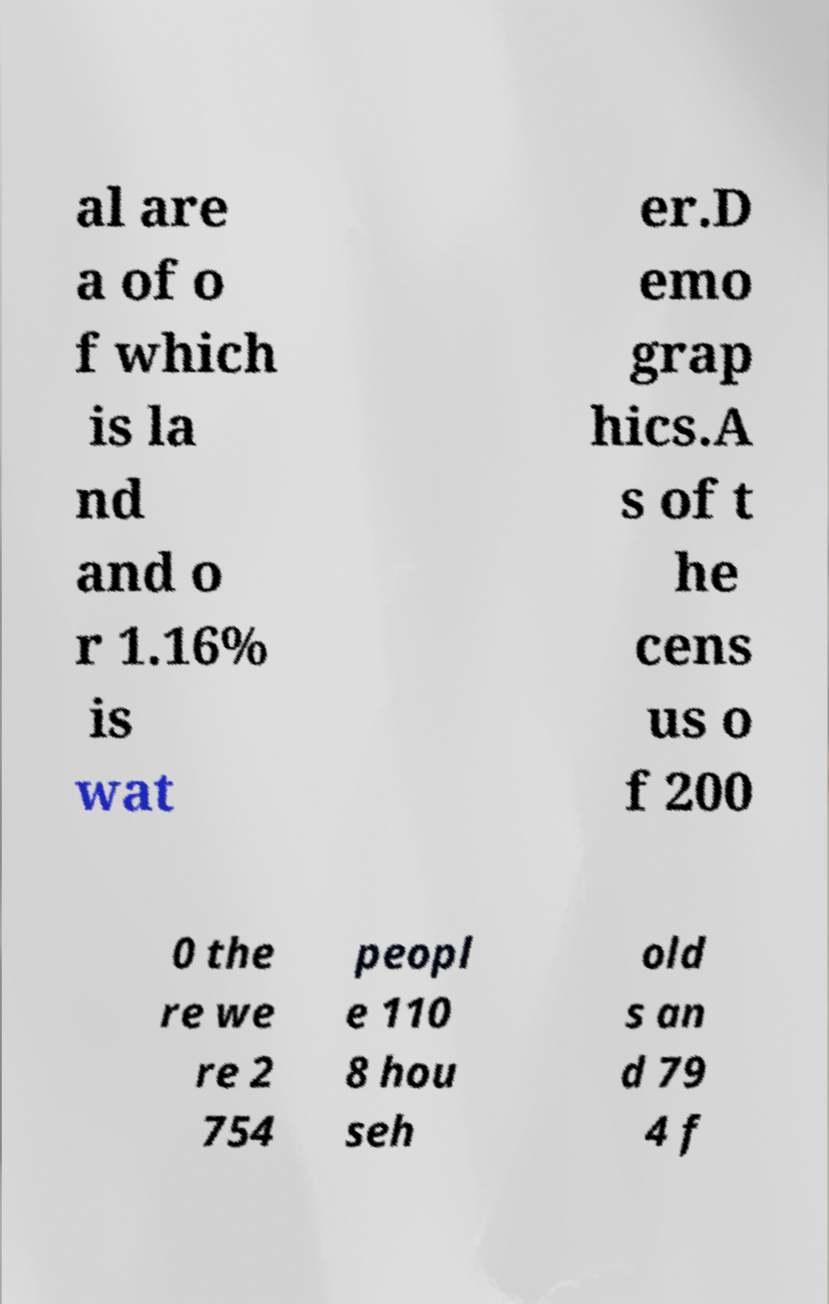There's text embedded in this image that I need extracted. Can you transcribe it verbatim? al are a of o f which is la nd and o r 1.16% is wat er.D emo grap hics.A s of t he cens us o f 200 0 the re we re 2 754 peopl e 110 8 hou seh old s an d 79 4 f 